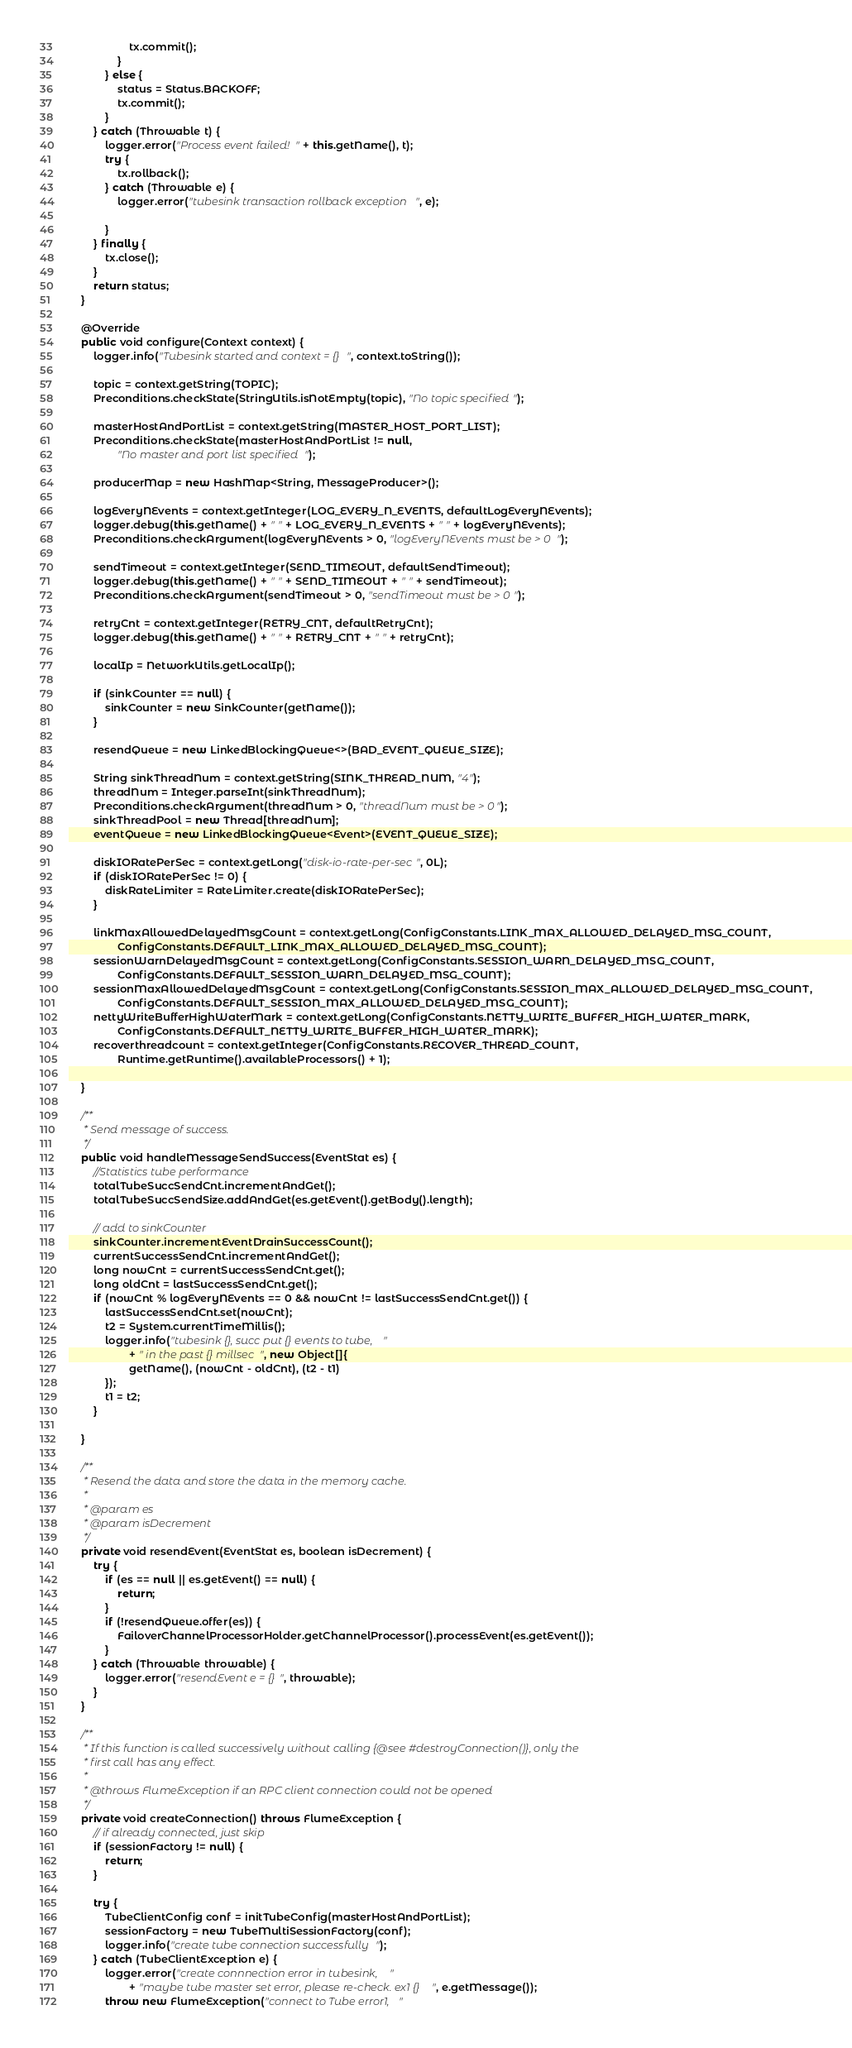<code> <loc_0><loc_0><loc_500><loc_500><_Java_>                    tx.commit();
                }
            } else {
                status = Status.BACKOFF;
                tx.commit();
            }
        } catch (Throwable t) {
            logger.error("Process event failed!" + this.getName(), t);
            try {
                tx.rollback();
            } catch (Throwable e) {
                logger.error("tubesink transaction rollback exception", e);

            }
        } finally {
            tx.close();
        }
        return status;
    }

    @Override
    public void configure(Context context) {
        logger.info("Tubesink started and context = {}", context.toString());

        topic = context.getString(TOPIC);
        Preconditions.checkState(StringUtils.isNotEmpty(topic), "No topic specified");

        masterHostAndPortList = context.getString(MASTER_HOST_PORT_LIST);
        Preconditions.checkState(masterHostAndPortList != null,
                "No master and port list specified");

        producerMap = new HashMap<String, MessageProducer>();

        logEveryNEvents = context.getInteger(LOG_EVERY_N_EVENTS, defaultLogEveryNEvents);
        logger.debug(this.getName() + " " + LOG_EVERY_N_EVENTS + " " + logEveryNEvents);
        Preconditions.checkArgument(logEveryNEvents > 0, "logEveryNEvents must be > 0");

        sendTimeout = context.getInteger(SEND_TIMEOUT, defaultSendTimeout);
        logger.debug(this.getName() + " " + SEND_TIMEOUT + " " + sendTimeout);
        Preconditions.checkArgument(sendTimeout > 0, "sendTimeout must be > 0");

        retryCnt = context.getInteger(RETRY_CNT, defaultRetryCnt);
        logger.debug(this.getName() + " " + RETRY_CNT + " " + retryCnt);

        localIp = NetworkUtils.getLocalIp();

        if (sinkCounter == null) {
            sinkCounter = new SinkCounter(getName());
        }

        resendQueue = new LinkedBlockingQueue<>(BAD_EVENT_QUEUE_SIZE);

        String sinkThreadNum = context.getString(SINK_THREAD_NUM, "4");
        threadNum = Integer.parseInt(sinkThreadNum);
        Preconditions.checkArgument(threadNum > 0, "threadNum must be > 0");
        sinkThreadPool = new Thread[threadNum];
        eventQueue = new LinkedBlockingQueue<Event>(EVENT_QUEUE_SIZE);

        diskIORatePerSec = context.getLong("disk-io-rate-per-sec", 0L);
        if (diskIORatePerSec != 0) {
            diskRateLimiter = RateLimiter.create(diskIORatePerSec);
        }

        linkMaxAllowedDelayedMsgCount = context.getLong(ConfigConstants.LINK_MAX_ALLOWED_DELAYED_MSG_COUNT,
                ConfigConstants.DEFAULT_LINK_MAX_ALLOWED_DELAYED_MSG_COUNT);
        sessionWarnDelayedMsgCount = context.getLong(ConfigConstants.SESSION_WARN_DELAYED_MSG_COUNT,
                ConfigConstants.DEFAULT_SESSION_WARN_DELAYED_MSG_COUNT);
        sessionMaxAllowedDelayedMsgCount = context.getLong(ConfigConstants.SESSION_MAX_ALLOWED_DELAYED_MSG_COUNT,
                ConfigConstants.DEFAULT_SESSION_MAX_ALLOWED_DELAYED_MSG_COUNT);
        nettyWriteBufferHighWaterMark = context.getLong(ConfigConstants.NETTY_WRITE_BUFFER_HIGH_WATER_MARK,
                ConfigConstants.DEFAULT_NETTY_WRITE_BUFFER_HIGH_WATER_MARK);
        recoverthreadcount = context.getInteger(ConfigConstants.RECOVER_THREAD_COUNT,
                Runtime.getRuntime().availableProcessors() + 1);

    }

    /**
     * Send message of success.
     */
    public void handleMessageSendSuccess(EventStat es) {
        //Statistics tube performance
        totalTubeSuccSendCnt.incrementAndGet();
        totalTubeSuccSendSize.addAndGet(es.getEvent().getBody().length);

        // add to sinkCounter
        sinkCounter.incrementEventDrainSuccessCount();
        currentSuccessSendCnt.incrementAndGet();
        long nowCnt = currentSuccessSendCnt.get();
        long oldCnt = lastSuccessSendCnt.get();
        if (nowCnt % logEveryNEvents == 0 && nowCnt != lastSuccessSendCnt.get()) {
            lastSuccessSendCnt.set(nowCnt);
            t2 = System.currentTimeMillis();
            logger.info("tubesink {}, succ put {} events to tube,"
                    + " in the past {} millsec", new Object[]{
                    getName(), (nowCnt - oldCnt), (t2 - t1)
            });
            t1 = t2;
        }

    }

    /**
     * Resend the data and store the data in the memory cache.
     *
     * @param es
     * @param isDecrement
     */
    private void resendEvent(EventStat es, boolean isDecrement) {
        try {
            if (es == null || es.getEvent() == null) {
                return;
            }
            if (!resendQueue.offer(es)) {
                FailoverChannelProcessorHolder.getChannelProcessor().processEvent(es.getEvent());
            }
        } catch (Throwable throwable) {
            logger.error("resendEvent e = {}", throwable);
        }
    }

    /**
     * If this function is called successively without calling {@see #destroyConnection()}, only the
     * first call has any effect.
     *
     * @throws FlumeException if an RPC client connection could not be opened
     */
    private void createConnection() throws FlumeException {
        // if already connected, just skip
        if (sessionFactory != null) {
            return;
        }

        try {
            TubeClientConfig conf = initTubeConfig(masterHostAndPortList);
            sessionFactory = new TubeMultiSessionFactory(conf);
            logger.info("create tube connection successfully");
        } catch (TubeClientException e) {
            logger.error("create connnection error in tubesink, "
                    + "maybe tube master set error, please re-check. ex1 {}", e.getMessage());
            throw new FlumeException("connect to Tube error1, "</code> 